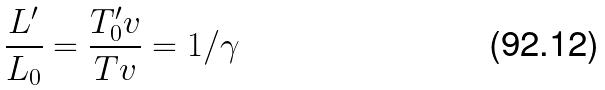<formula> <loc_0><loc_0><loc_500><loc_500>\frac { L ^ { \prime } } { L _ { 0 } } = \frac { T _ { 0 } ^ { \prime } v } { T v } = 1 / \gamma</formula> 